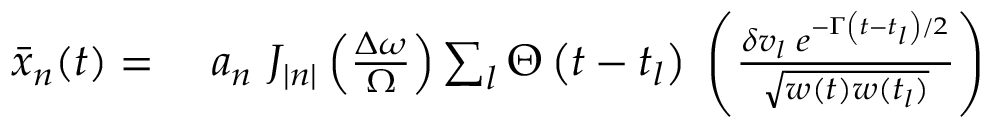Convert formula to latex. <formula><loc_0><loc_0><loc_500><loc_500>\begin{array} { r l } { \bar { x } _ { n } ( t ) = \ } & a _ { n } \ J _ { | n | } \left ( \frac { \Delta \omega } { \Omega } \right ) \sum _ { l } \Theta \left ( t - t _ { l } \right ) \, \left ( \frac { \delta v _ { l } \, e ^ { - \Gamma \left ( t - t _ { l } \right ) / 2 } } { \sqrt { w ( t ) w ( t _ { l } ) } } \right ) } \end{array}</formula> 